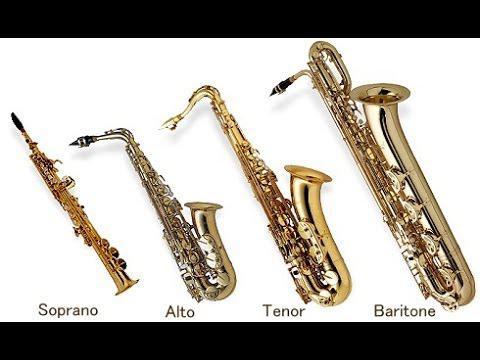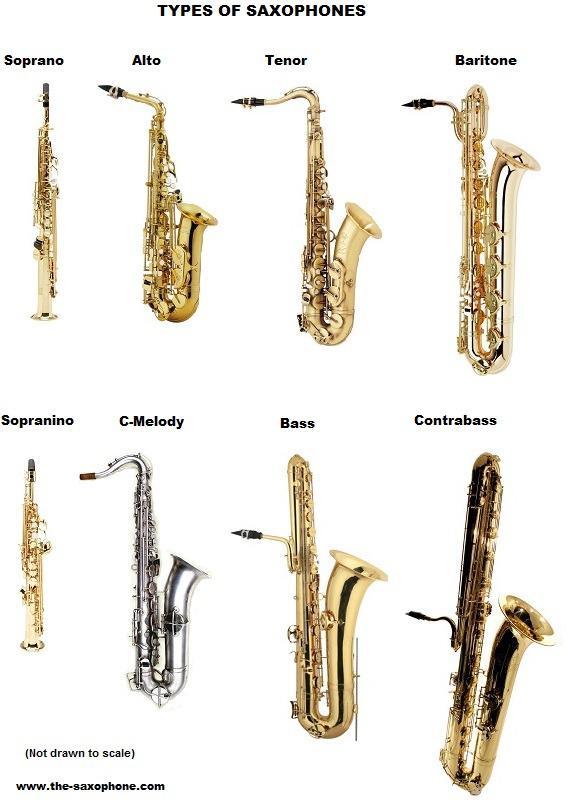The first image is the image on the left, the second image is the image on the right. Considering the images on both sides, is "Neither of the images in the pair show more than three saxophones." valid? Answer yes or no. No. The first image is the image on the left, the second image is the image on the right. Considering the images on both sides, is "There is a soprano saxophone labeled." valid? Answer yes or no. Yes. 